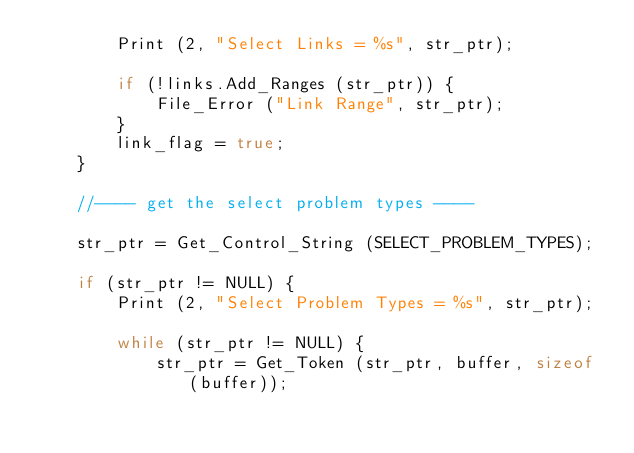Convert code to text. <code><loc_0><loc_0><loc_500><loc_500><_C++_>		Print (2, "Select Links = %s", str_ptr);

		if (!links.Add_Ranges (str_ptr)) {
			File_Error ("Link Range", str_ptr);
		}
		link_flag = true;
	}

	//---- get the select problem types ----
	
	str_ptr = Get_Control_String (SELECT_PROBLEM_TYPES);

	if (str_ptr != NULL) {
		Print (2, "Select Problem Types = %s", str_ptr);

		while (str_ptr != NULL) {
			str_ptr = Get_Token (str_ptr, buffer, sizeof (buffer));
</code> 